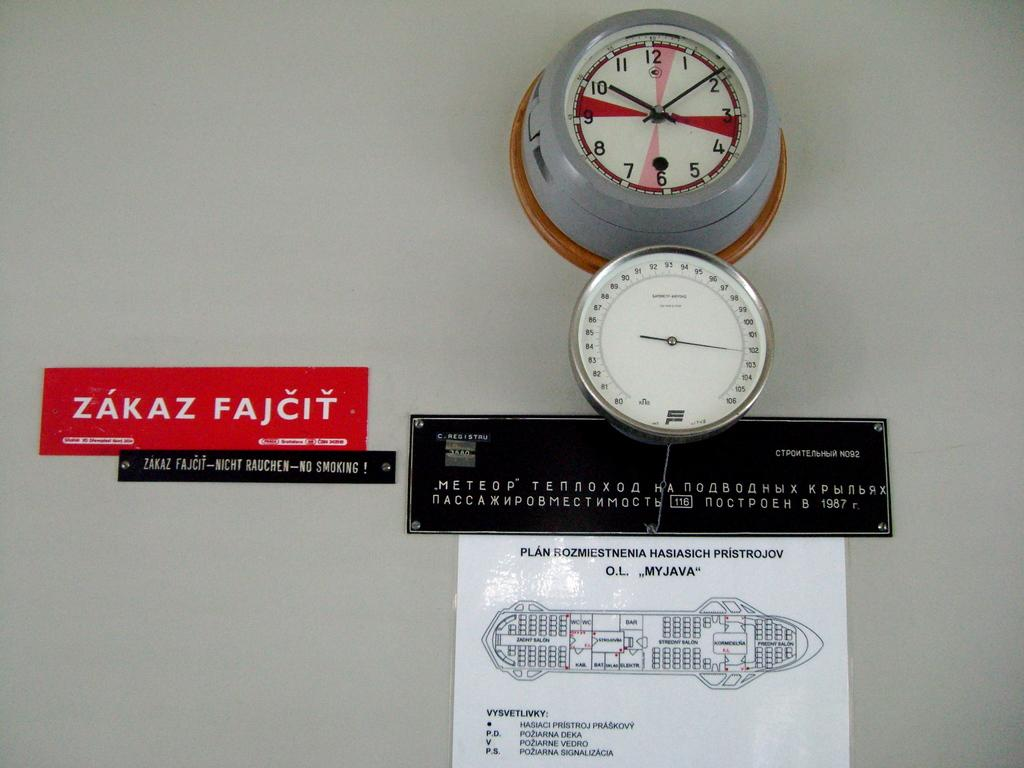<image>
Render a clear and concise summary of the photo. Two meters are on the wall with a map below it and there is a red sign that says Zakaz Fajcit on it. 